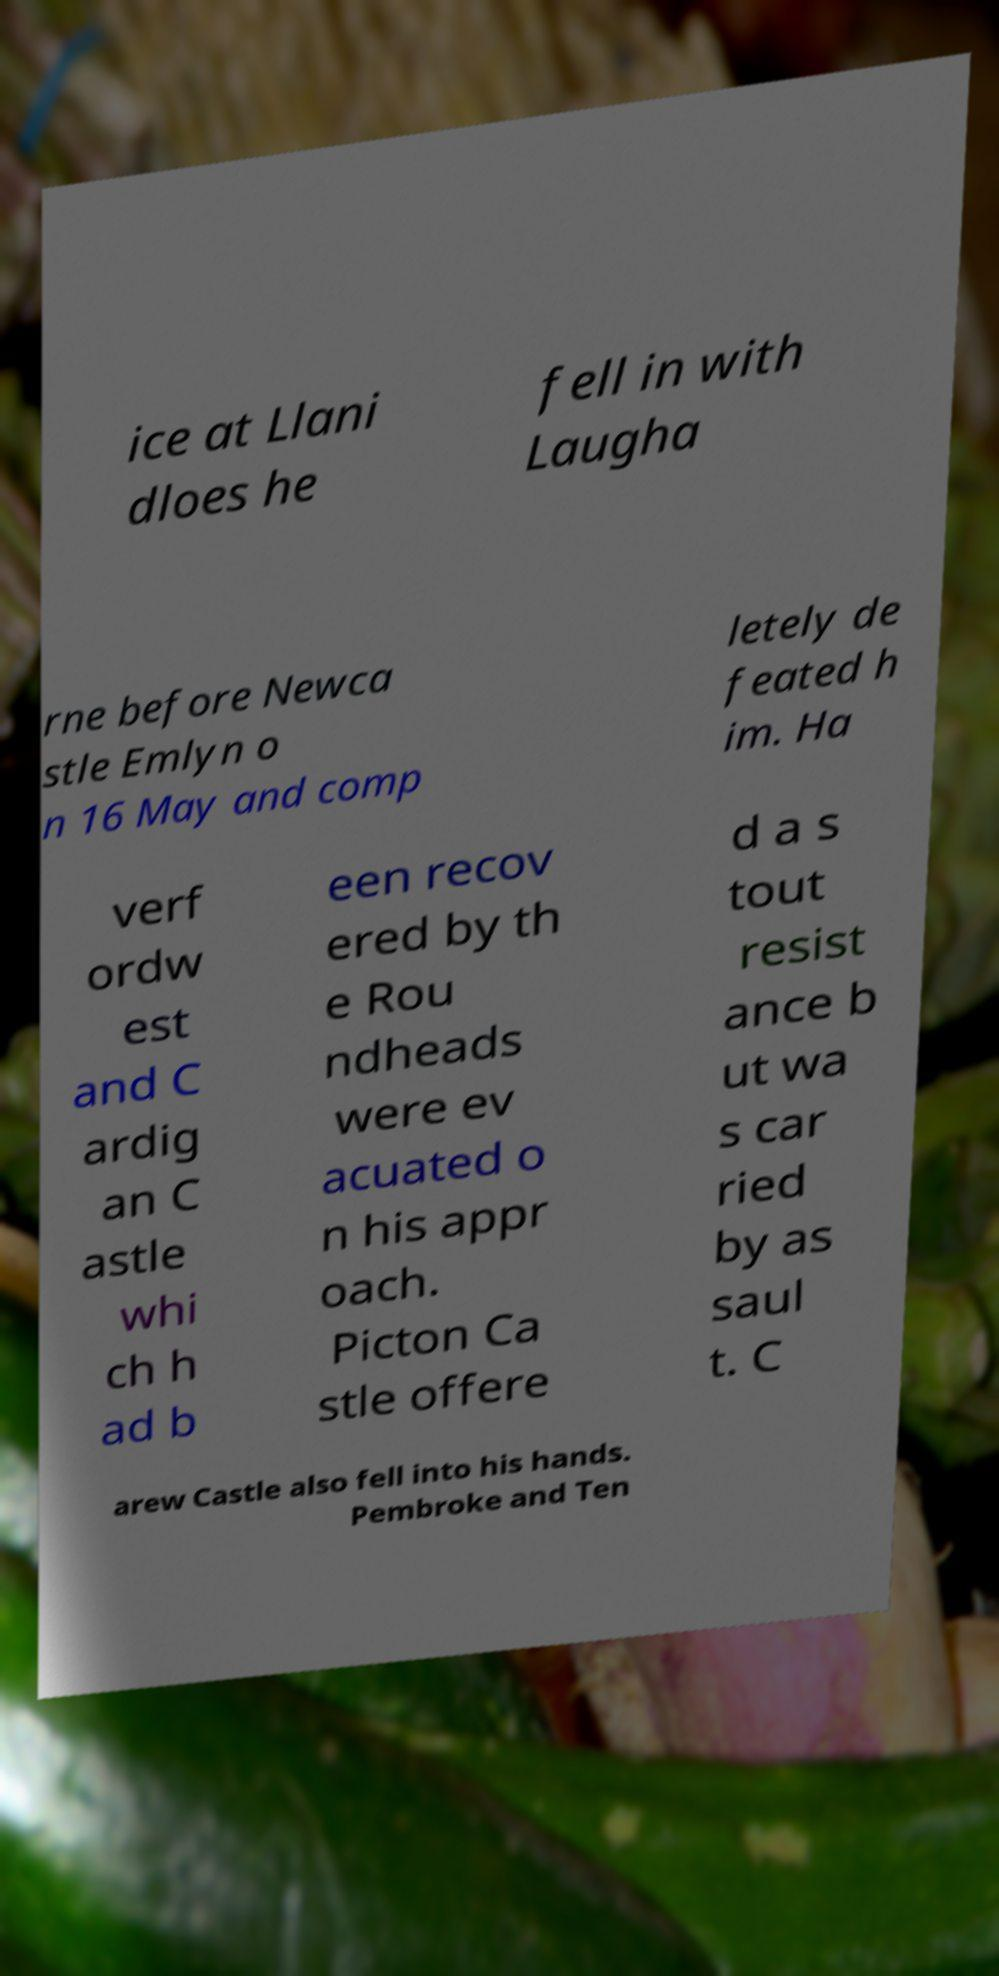For documentation purposes, I need the text within this image transcribed. Could you provide that? ice at Llani dloes he fell in with Laugha rne before Newca stle Emlyn o n 16 May and comp letely de feated h im. Ha verf ordw est and C ardig an C astle whi ch h ad b een recov ered by th e Rou ndheads were ev acuated o n his appr oach. Picton Ca stle offere d a s tout resist ance b ut wa s car ried by as saul t. C arew Castle also fell into his hands. Pembroke and Ten 